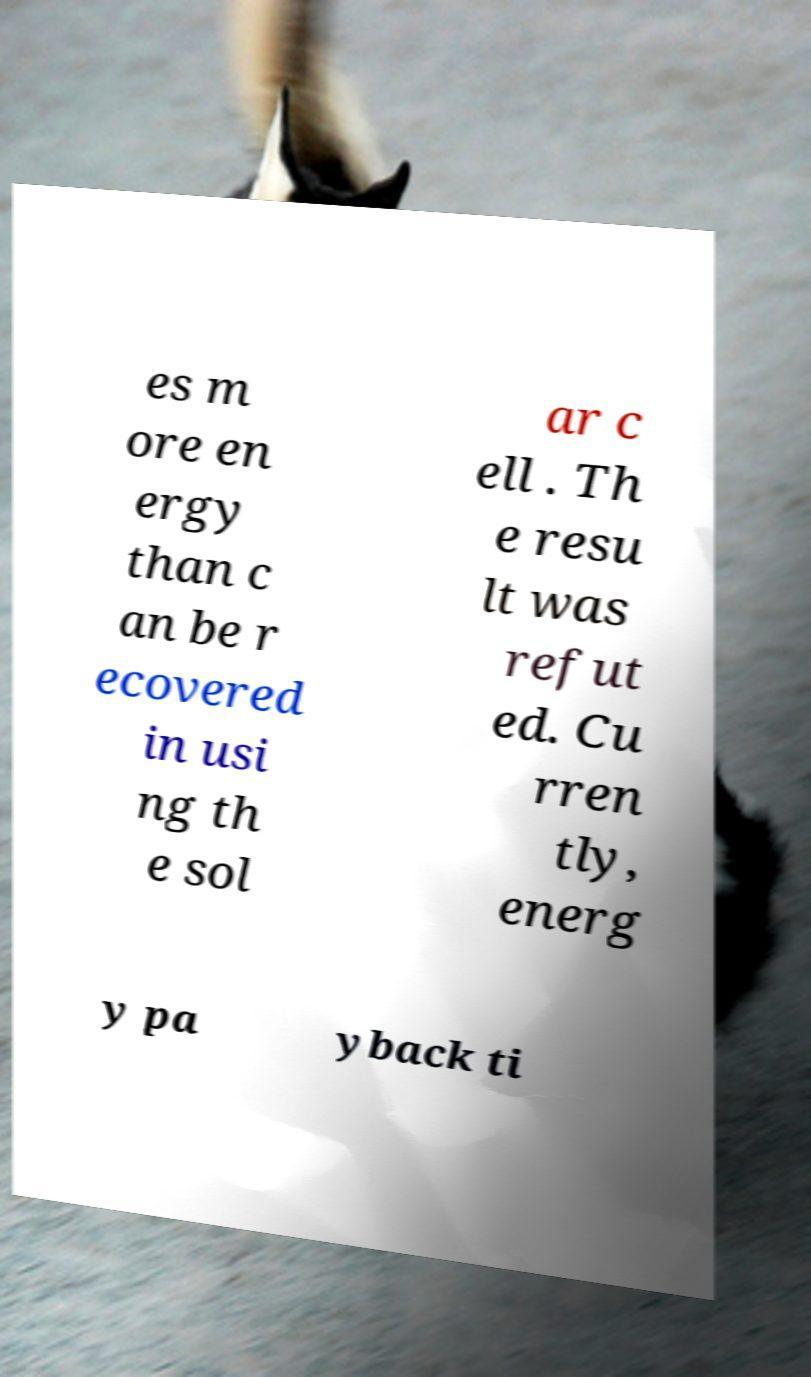Can you accurately transcribe the text from the provided image for me? es m ore en ergy than c an be r ecovered in usi ng th e sol ar c ell . Th e resu lt was refut ed. Cu rren tly, energ y pa yback ti 